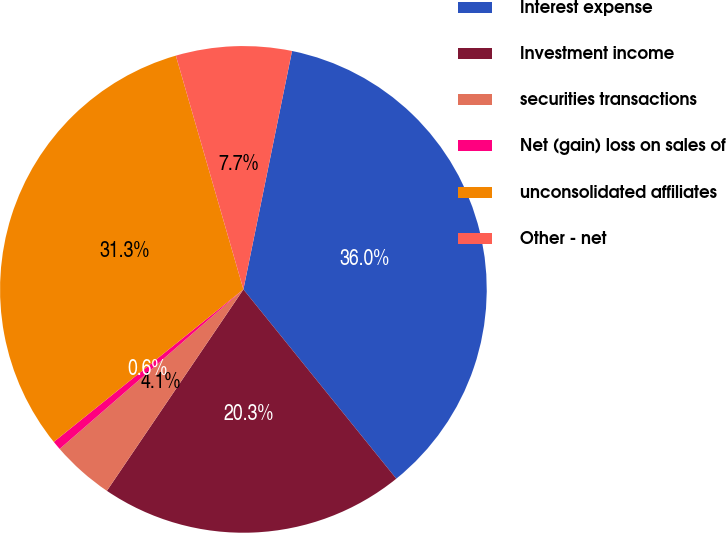Convert chart to OTSL. <chart><loc_0><loc_0><loc_500><loc_500><pie_chart><fcel>Interest expense<fcel>Investment income<fcel>securities transactions<fcel>Net (gain) loss on sales of<fcel>unconsolidated affiliates<fcel>Other - net<nl><fcel>35.98%<fcel>20.29%<fcel>4.14%<fcel>0.6%<fcel>31.3%<fcel>7.68%<nl></chart> 